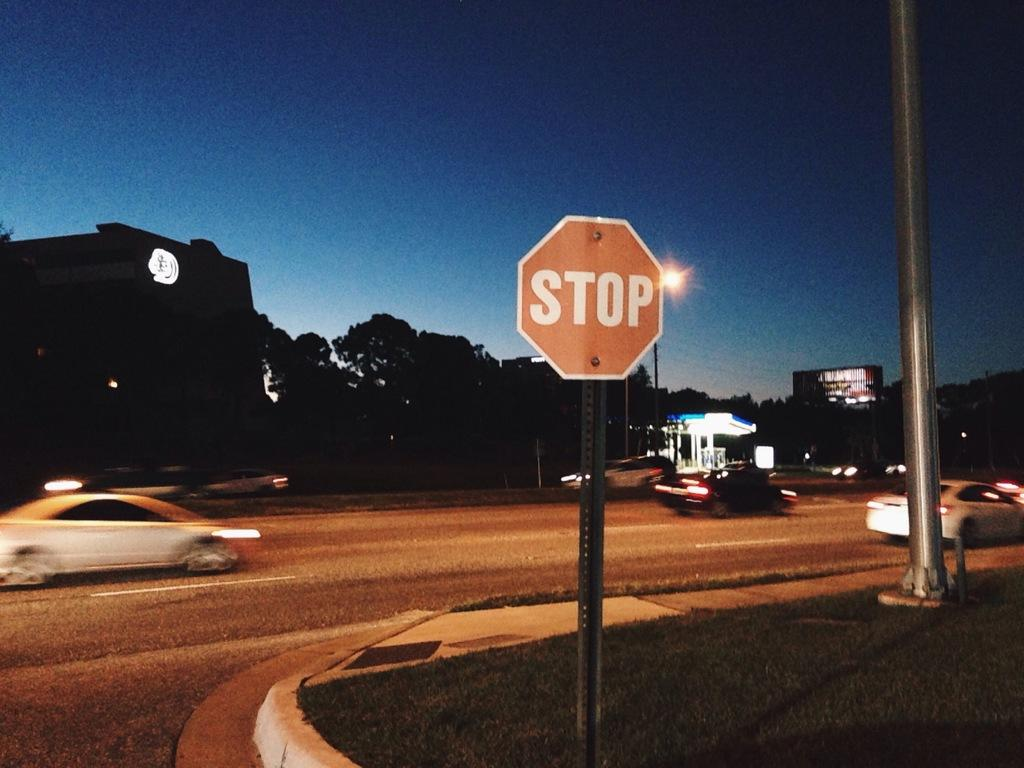Provide a one-sentence caption for the provided image. A stop sign is in the grass next to end of the road. 